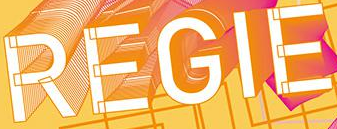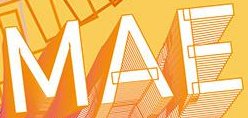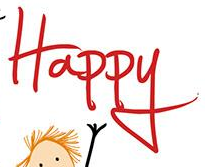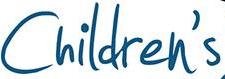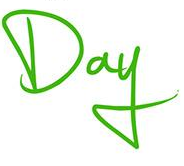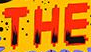What words are shown in these images in order, separated by a semicolon? REGIE; MAE; Happy; Children's; Day; THE 